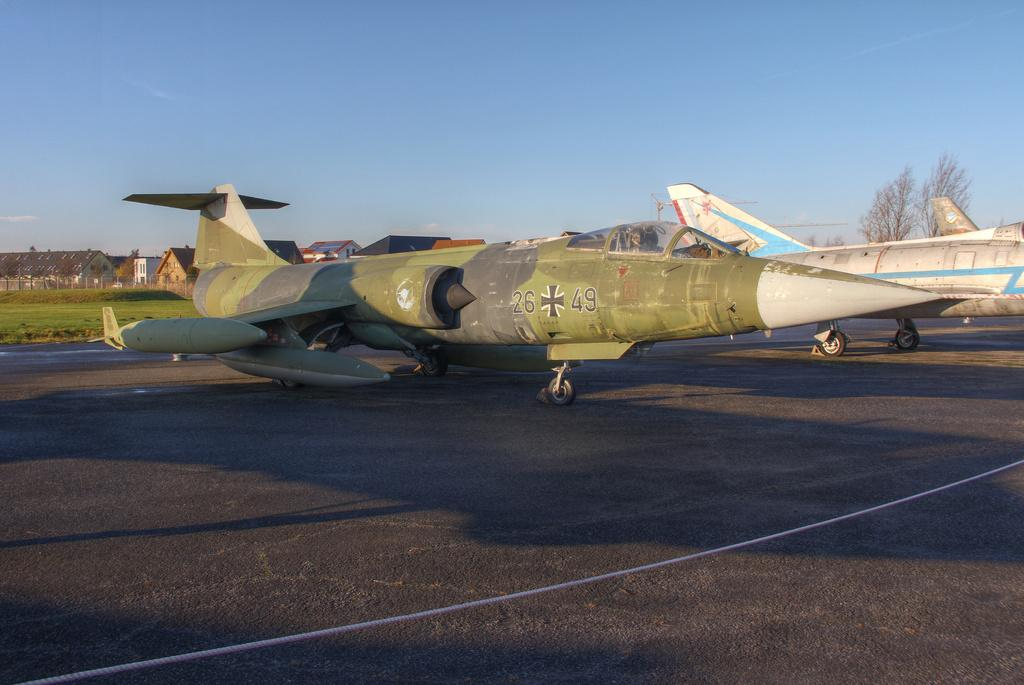<image>
Summarize the visual content of the image. A green military jet is labeled 26 49. 